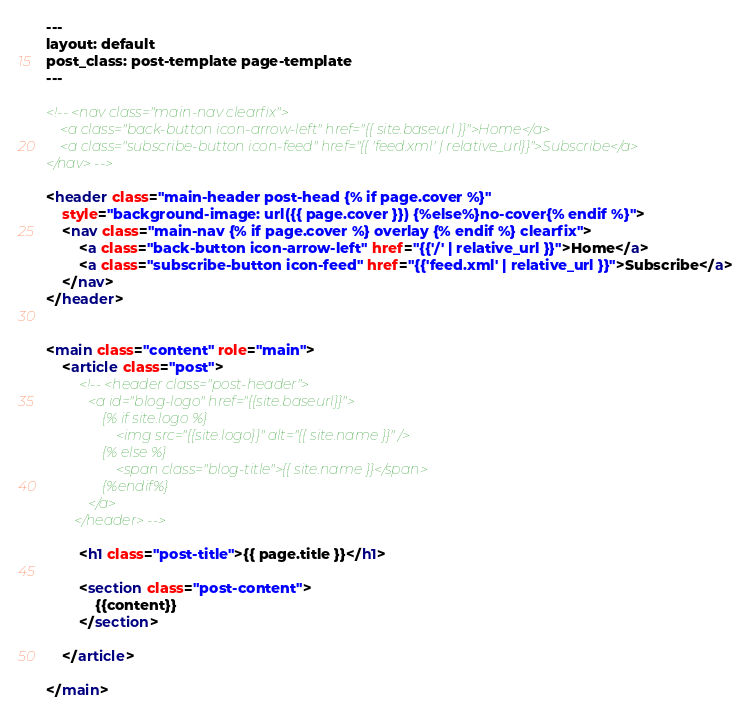<code> <loc_0><loc_0><loc_500><loc_500><_HTML_>---
layout: default
post_class: post-template page-template
---

<!-- <nav class="main-nav clearfix">
    <a class="back-button icon-arrow-left" href="{{ site.baseurl }}">Home</a>
    <a class="subscribe-button icon-feed" href="{{ 'feed.xml' | relative_url}}">Subscribe</a>
</nav> -->

<header class="main-header post-head {% if page.cover %}"
    style="background-image: url({{ page.cover }}) {%else%}no-cover{% endif %}">
    <nav class="main-nav {% if page.cover %} overlay {% endif %} clearfix">
        <a class="back-button icon-arrow-left" href="{{'/' | relative_url }}">Home</a>
        <a class="subscribe-button icon-feed" href="{{'feed.xml' | relative_url }}">Subscribe</a>
    </nav>
</header>


<main class="content" role="main">
    <article class="post">
        <!-- <header class="post-header">
            <a id="blog-logo" href="{{site.baseurl}}">
                {% if site.logo %}
                    <img src="{{site.logo}}" alt="{{ site.name }}" />
                {% else %}
                    <span class="blog-title">{{ site.name }}</span>
                {%endif%}
            </a>
        </header> -->

        <h1 class="post-title">{{ page.title }}</h1>

        <section class="post-content">
            {{content}}
        </section>

    </article>

</main>
</code> 